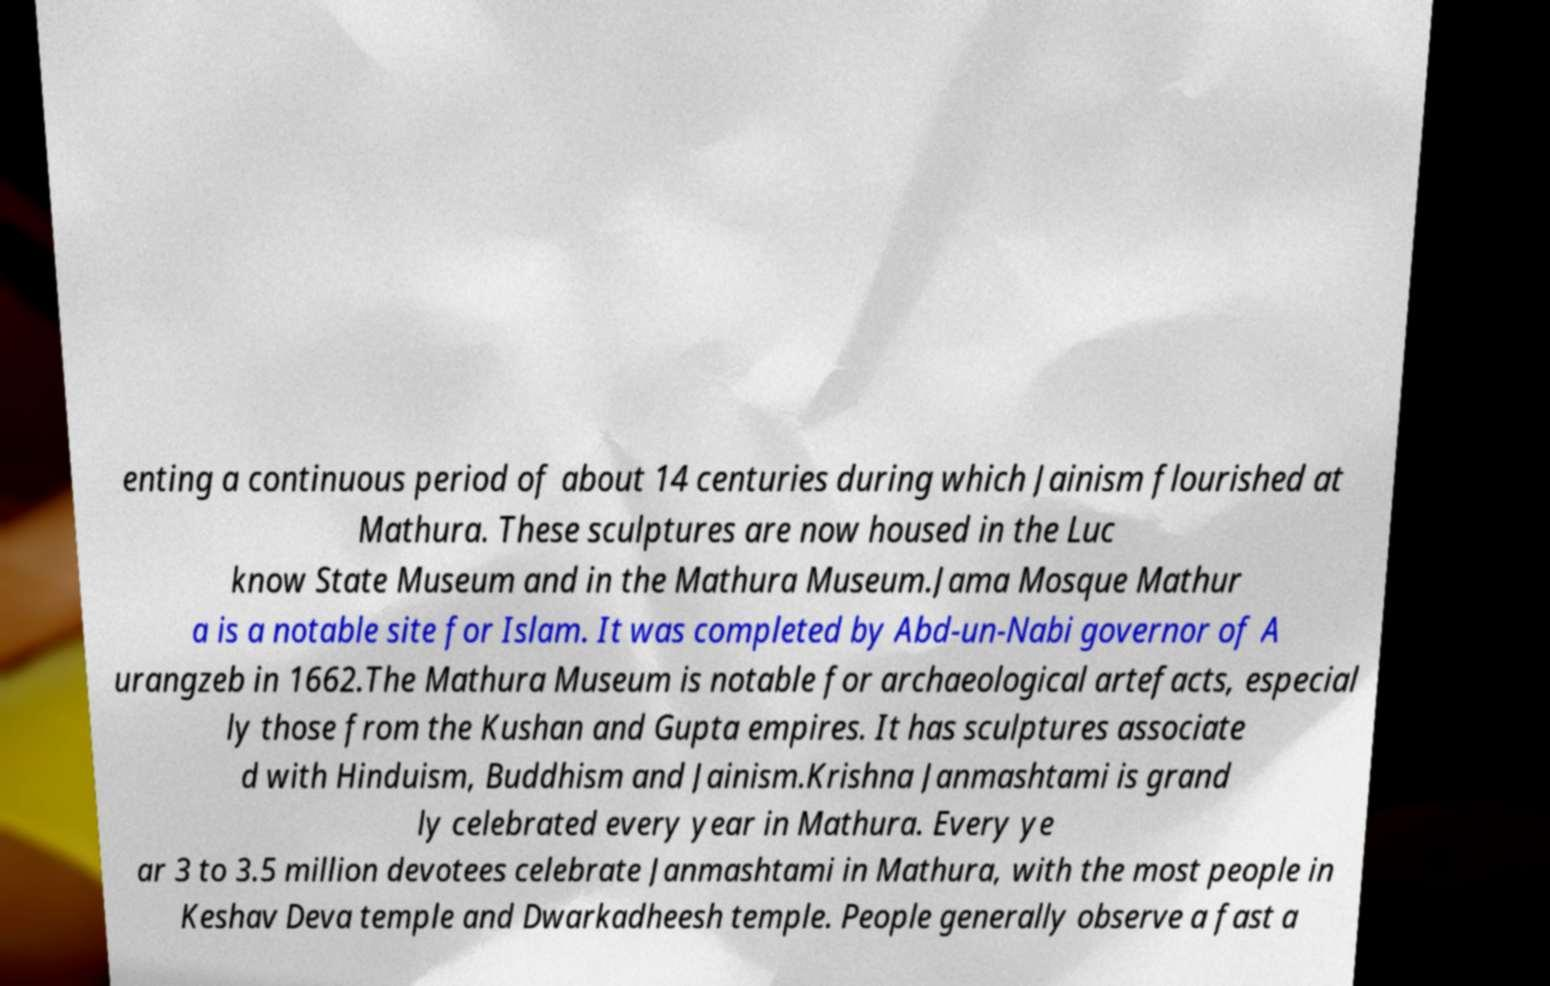Can you read and provide the text displayed in the image?This photo seems to have some interesting text. Can you extract and type it out for me? enting a continuous period of about 14 centuries during which Jainism flourished at Mathura. These sculptures are now housed in the Luc know State Museum and in the Mathura Museum.Jama Mosque Mathur a is a notable site for Islam. It was completed by Abd-un-Nabi governor of A urangzeb in 1662.The Mathura Museum is notable for archaeological artefacts, especial ly those from the Kushan and Gupta empires. It has sculptures associate d with Hinduism, Buddhism and Jainism.Krishna Janmashtami is grand ly celebrated every year in Mathura. Every ye ar 3 to 3.5 million devotees celebrate Janmashtami in Mathura, with the most people in Keshav Deva temple and Dwarkadheesh temple. People generally observe a fast a 